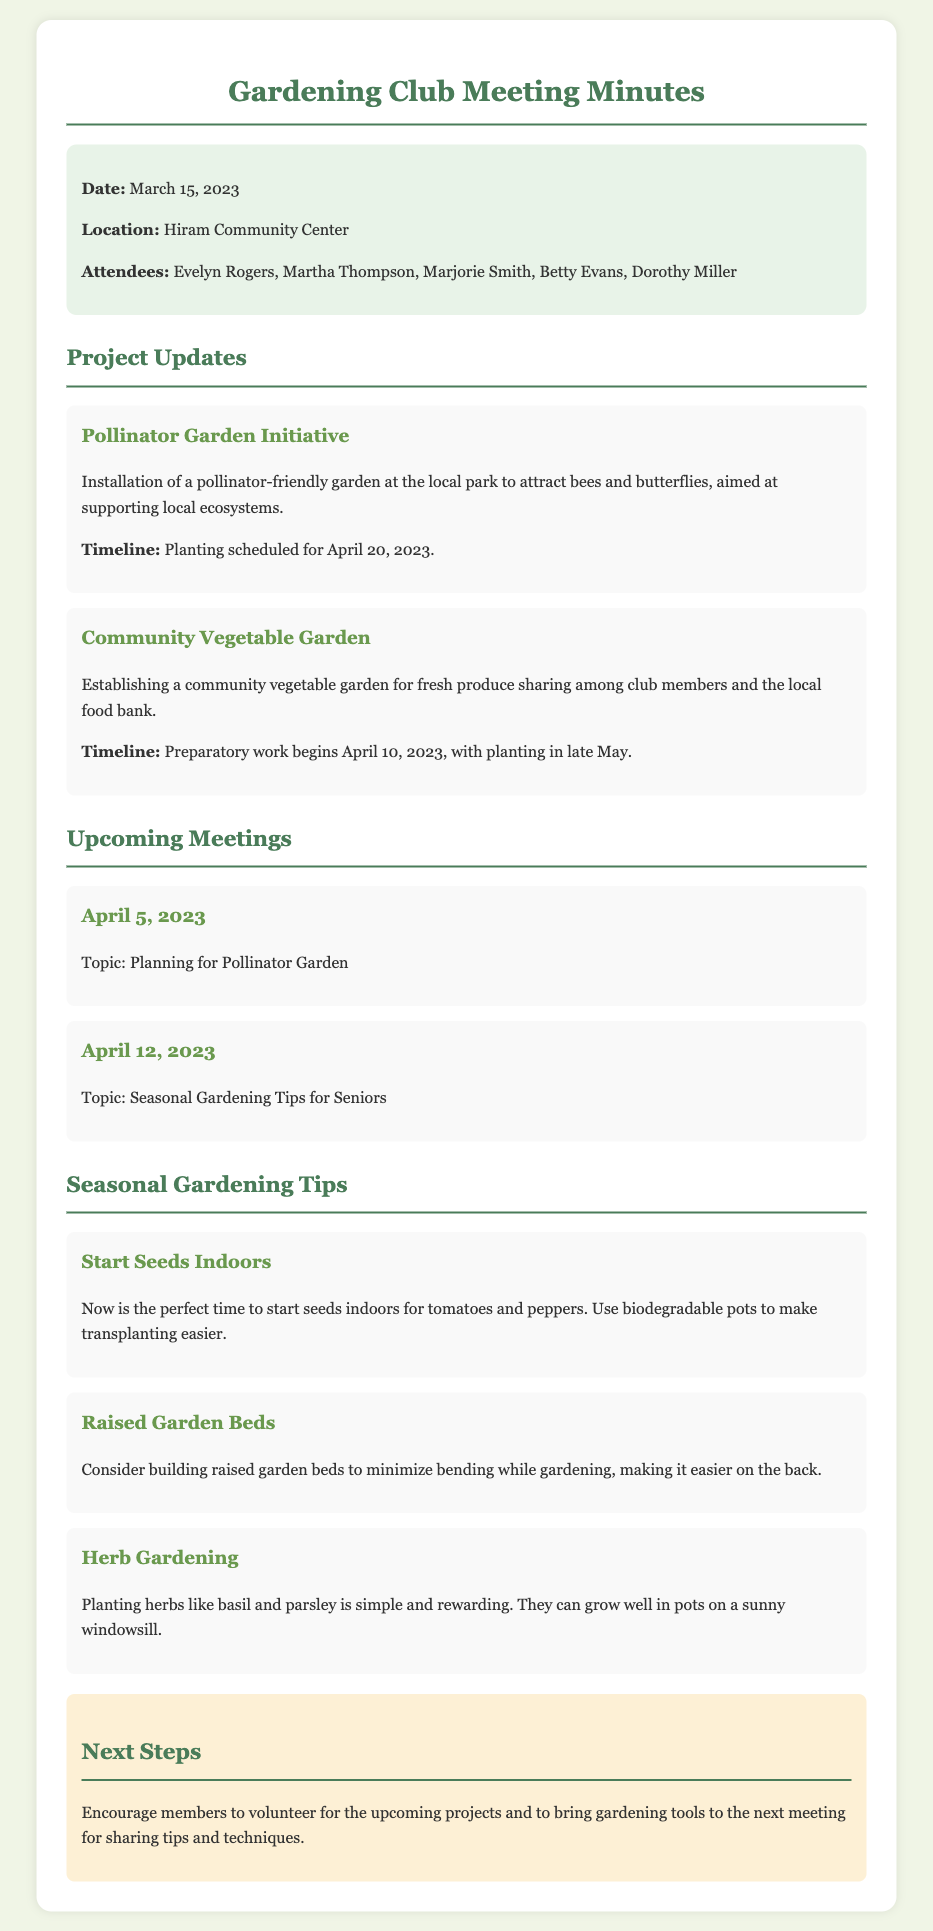What is the date of the meeting? The date of the meeting is mentioned in the document as March 15, 2023.
Answer: March 15, 2023 Where will the next meeting take place? The location of the meeting is specified as Hiram Community Center in the document.
Answer: Hiram Community Center What is the first project mentioned in the meeting minutes? The first project refers to the "Pollinator Garden Initiative" discussed in the project updates section.
Answer: Pollinator Garden Initiative When is the planting scheduled for the Pollinator Garden? The document specifies that planting for the Pollinator Garden is scheduled for April 20, 2023.
Answer: April 20, 2023 What topic will be discussed on April 12, 2023? The topic for the meeting on April 12, 2023, is stated in the minutes as "Seasonal Gardening Tips for Seniors."
Answer: Seasonal Gardening Tips for Seniors How can seniors benefit from raised garden beds? The document mentions raised garden beds help minimize bending, making it easier on the back while gardening.
Answer: Minimize bending What herbs are suggested for planting? The minutes provide recommendations for planting basil and parsley as simple and rewarding herb options.
Answer: Basil and parsley What should members bring to the next meeting? The document advises members to bring gardening tools to the next meeting for sharing tips and techniques.
Answer: Gardening tools 